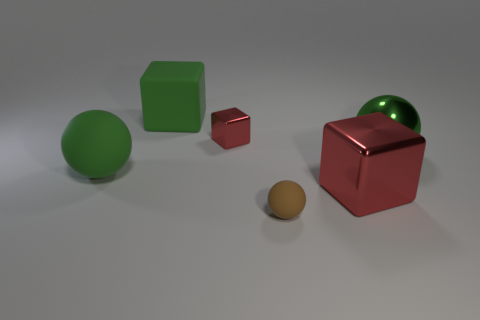There is a metallic thing that is the same color as the large matte sphere; what is its shape?
Provide a succinct answer. Sphere. What color is the metal sphere that is the same size as the rubber cube?
Offer a terse response. Green. Are there any matte cubes of the same color as the large matte sphere?
Provide a succinct answer. Yes. Do the red object that is behind the big rubber ball and the red metallic object that is on the right side of the brown sphere have the same shape?
Your response must be concise. Yes. There is another ball that is the same color as the shiny sphere; what size is it?
Ensure brevity in your answer.  Large. How many other objects are there of the same size as the green rubber cube?
Keep it short and to the point. 3. Does the large shiny sphere have the same color as the big sphere in front of the metal sphere?
Give a very brief answer. Yes. Are there fewer big shiny things to the right of the small block than big blocks on the left side of the large green block?
Keep it short and to the point. No. There is a object that is in front of the green rubber ball and behind the tiny brown matte thing; what is its color?
Ensure brevity in your answer.  Red. Is the size of the brown matte sphere the same as the red metallic block in front of the small shiny cube?
Offer a terse response. No. 